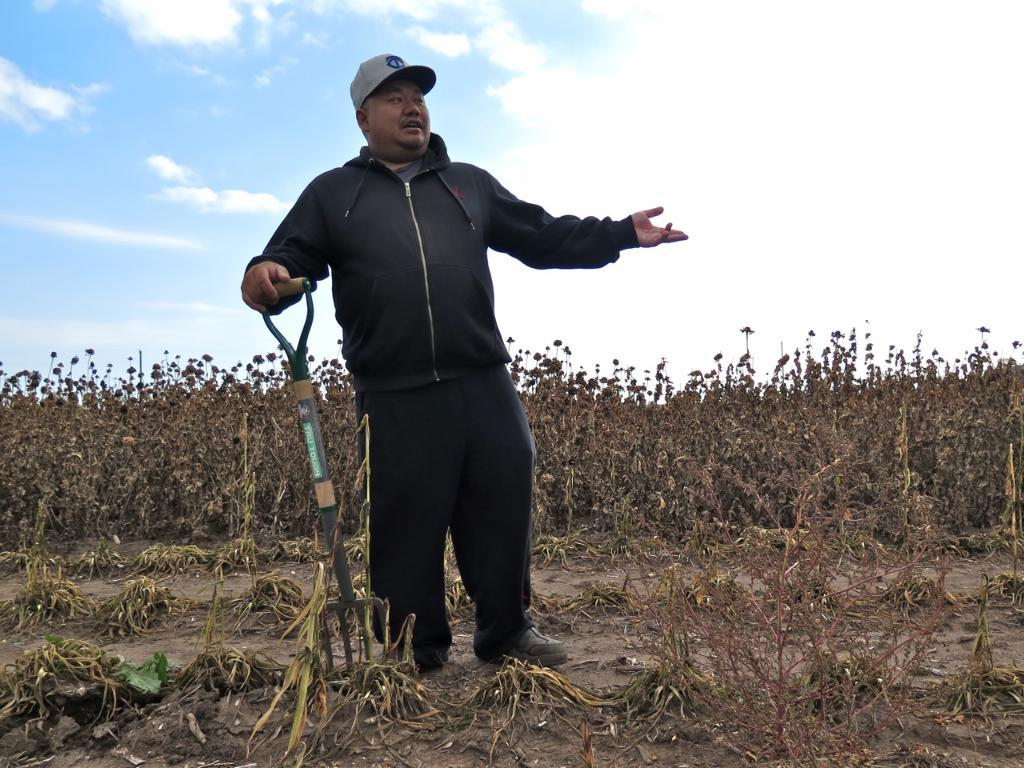What is the person in the image doing? The person is carrying an object in the image. What can be seen beneath the person's feet? The ground is visible in the image. What type of vegetation is present on the ground? Plants are present on the ground. What is visible above the person in the image? The sky is visible in the image. What can be seen in the sky? Clouds are present in the sky. What type of roof can be seen on the plants in the image? There is no roof present in the image, and the plants are not associated with any roof. 